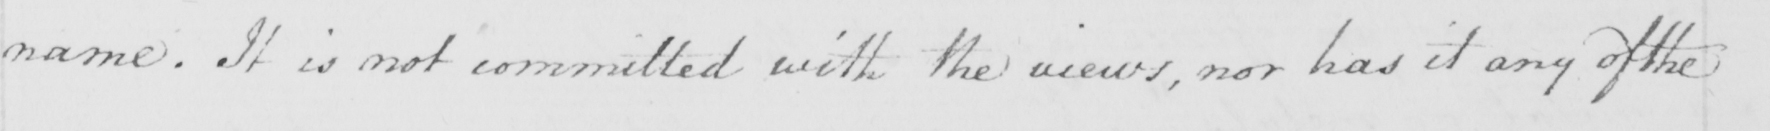Transcribe the text shown in this historical manuscript line. name . It is not committed with the views , nor has it any of the 